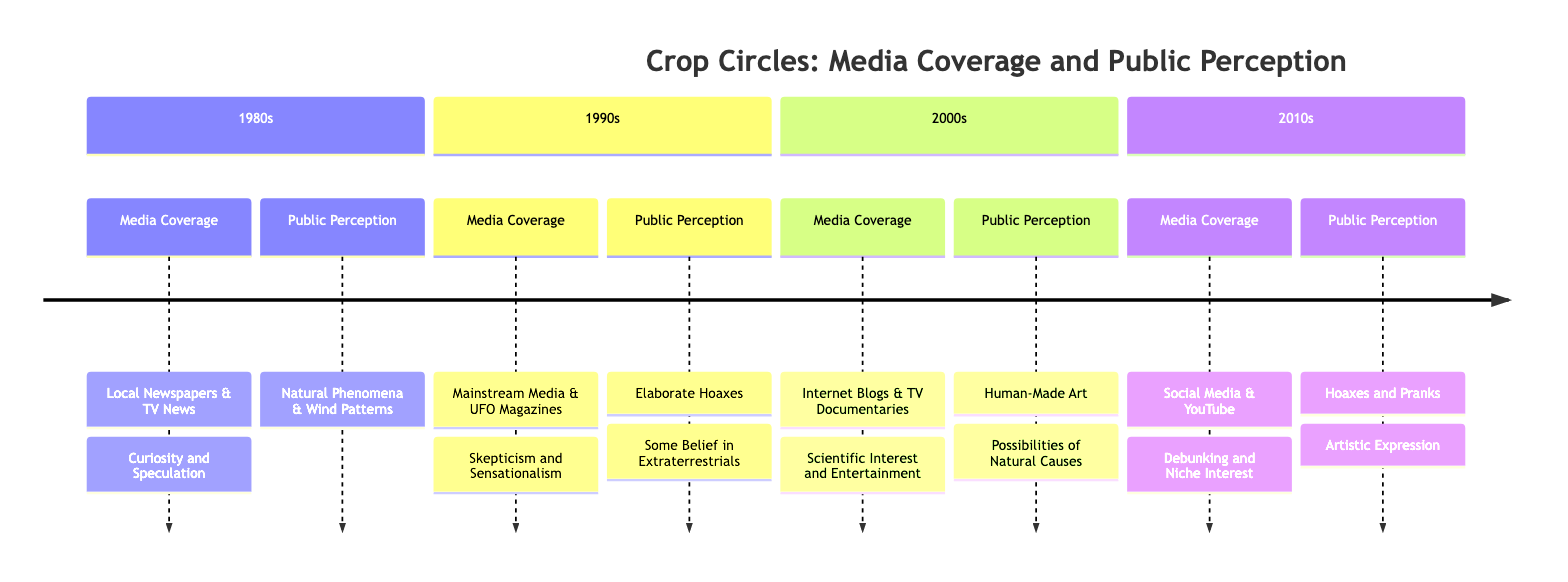What was the main source of media coverage in the 1980s? The diagram indicates that the main sources of media coverage in the 1980s were "Local Newspapers" and "Television News."
Answer: Local Newspapers, Television News What was the tone of media coverage in the 1990s? According to the diagram, the tone of media coverage in the 1990s was characterized as "Skepticism and Sensationalism."
Answer: Skepticism and Sensationalism How did public perception change from the 1980s to the 1990s? In the 1980s, public perception leaned towards "Natural Phenomena" and "Wind Patterns," while by the 1990s it shifted more towards "Elaborate Hoaxes" and a "Some Belief in Extraterrestrials." This shows a significant change towards skepticism regarding the origins of crop circles.
Answer: Shifted to Elaborate Hoaxes, Some Belief in Extraterrestrials What notable incident occurred in the 1990s? The timeline specifies "Doug Bower and Dave Chorley's 1991 Confession" as a notable incident in the 1990s, making it key in the understanding of crop circle phenomena.
Answer: Doug Bower and Dave Chorley's 1991 Confession What was the dominant belief in public perception during the 2000s? The dominant beliefs during the 2000s, as indicated in the diagram, were "Human-Made Art" and "Possibilities of Natural Causes," highlighting a shift towards more rational explanations compared to earlier decades.
Answer: Human-Made Art, Possibilities of Natural Causes How did social media influence media coverage in the 2010s? The diagram shows that in the 2010s, media coverage was primarily sourced from "Social Media" and "YouTube Channels," reflecting a shift from traditional media to platforms that enable direct audience engagement and content sharing.
Answer: Social Media, YouTube Channels Which decade saw a tone of "Debunking and Niche Interest"? The diagram indicates that the tone of media coverage characterized as "Debunking and Niche Interest" was found in the 2010s, suggesting a decline in broader interest in crop circles.
Answer: 2010s What influenced public perception the most in the 2010s? The influencing factors listed for the 2010s include "Debunking Videos" and "Declining Mainstream Interest," showing how these elements shaped how people viewed crop circles during this time.
Answer: Debunking Videos, Declining Mainstream Interest What type of sources dominated media coverage in the 2000s? The diagram states that in the 2000s, "Internet Blogs" and "TV Documentaries" were the primary sources of media coverage, representing a shift towards online content and more documentary-style explorations of the phenomenon.
Answer: Internet Blogs, TV Documentaries 